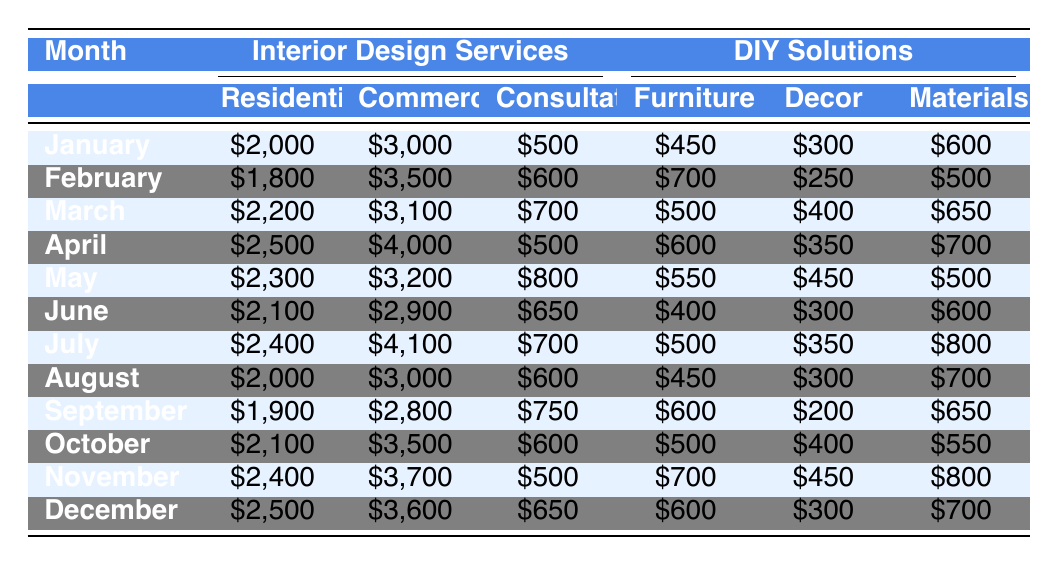What was the total expenditure on Interior Design Services in March? In March, the Residential expenditure is $2,200, Commercial is $3,100, and Consultation is $700. Adding these gives a total of $2,200 + $3,100 + $700 = $6,000.
Answer: $6,000 What is the difference in expenditure on DIY Solutions for Furniture between June and December? In June, the expenditure on Furniture is $400, while in December it is $600. The difference is $600 - $400 = $200.
Answer: $200 Which month had the highest expenditure on Interior Design Services for Commercial projects? The highest expenditure for Commercial projects is found in April, with a value of $4,000.
Answer: April What is the average expenditure on Decor for all months in 2023? The expenditures on Decor across all months are: $300, $250, $400, $350, $450, $300, $350, $300, $200, $400, $450, and $300. The total is $3,900, and there are 12 months, so the average is $3,900 / 12 = $325.
Answer: $325 In which month did the expenditure on DIY materials exceed that of DIY furniture? In July, the expenditure on Materials is $800 and that of Furniture is $500. This is the only month where Materials exceed Furniture.
Answer: July What is the total expenditure on Interior Design Services for the entire year? Summing all expenditures across all months gives: January ($5,500) + February ($5,900) + March ($6,000) + April ($6,100) + May ($6,300) + June ($5,650) + July ($6,200) + August ($5,600) + September ($5,450) + October ($6,200) + November ($6,600) + December ($6,750) = $73,800.
Answer: $73,800 Did the expenditure on Consultation services ever exceed $800 in any month? The highest expenditure on Consultation was $800 in May. Therefore, it did exceed $800 only once.
Answer: No Which type of DIY solution had the highest total expenditure over the year? Summing across all months for each type of DIY solution: Furniture ($6,850), Decor ($4,200), and Materials ($7,000). The highest is Materials with $7,000.
Answer: Materials How much did the expenditures on DIY solutions increase from January to April for Furniture? In January, the expenditure on Furniture is $450, and in April it is $600. The increase is $600 - $450 = $150.
Answer: $150 What is the total expenditure on Residential Interior Design Services from March to June? The expenditures for Residential from March to June are $2,200, $2,500, $2,300, and $2,100. Adding these gives $2,200 + $2,500 + $2,300 + $2,100 = $9,100.
Answer: $9,100 During which month was the expenditure on DIY Decor the lowest, and what was that amount? The lowest expenditure on DIY Decor was $200 in September.
Answer: September, $200 